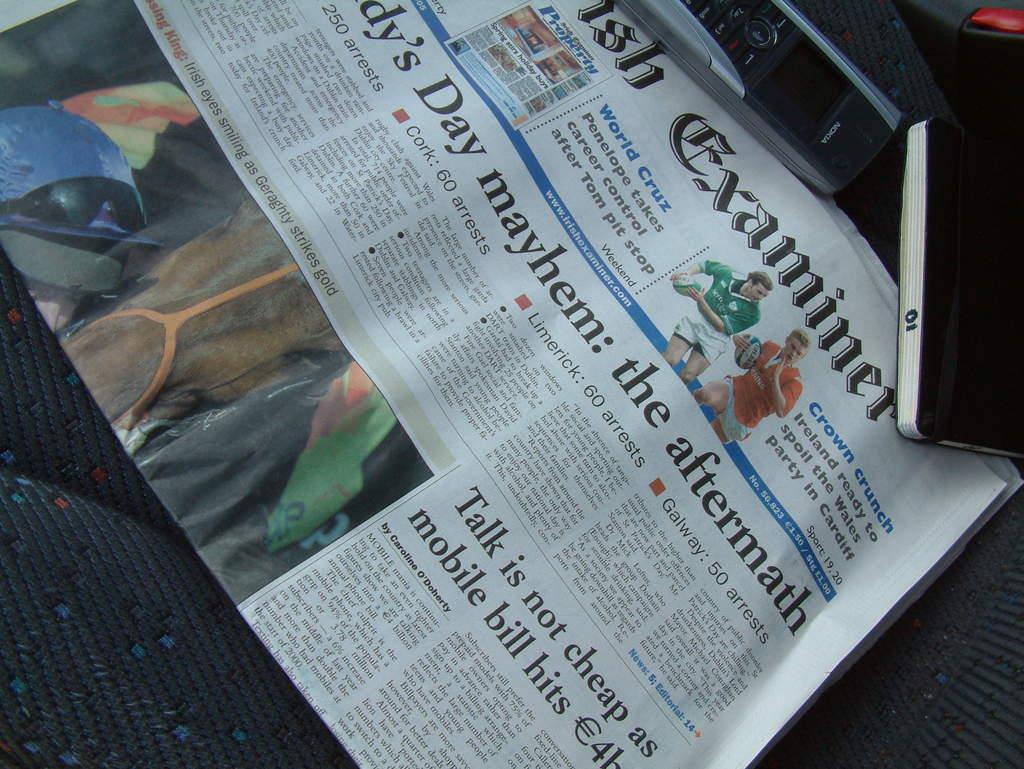What is not cheap?
Ensure brevity in your answer.  Talk. 